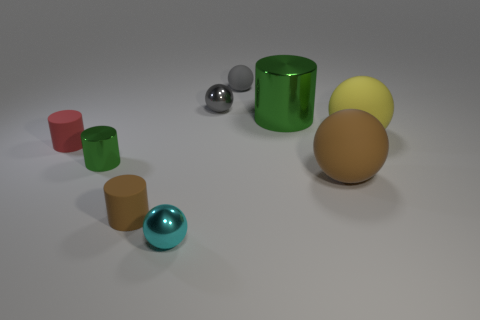Is the color of the big metallic cylinder the same as the shiny cylinder on the left side of the cyan shiny thing? yes 